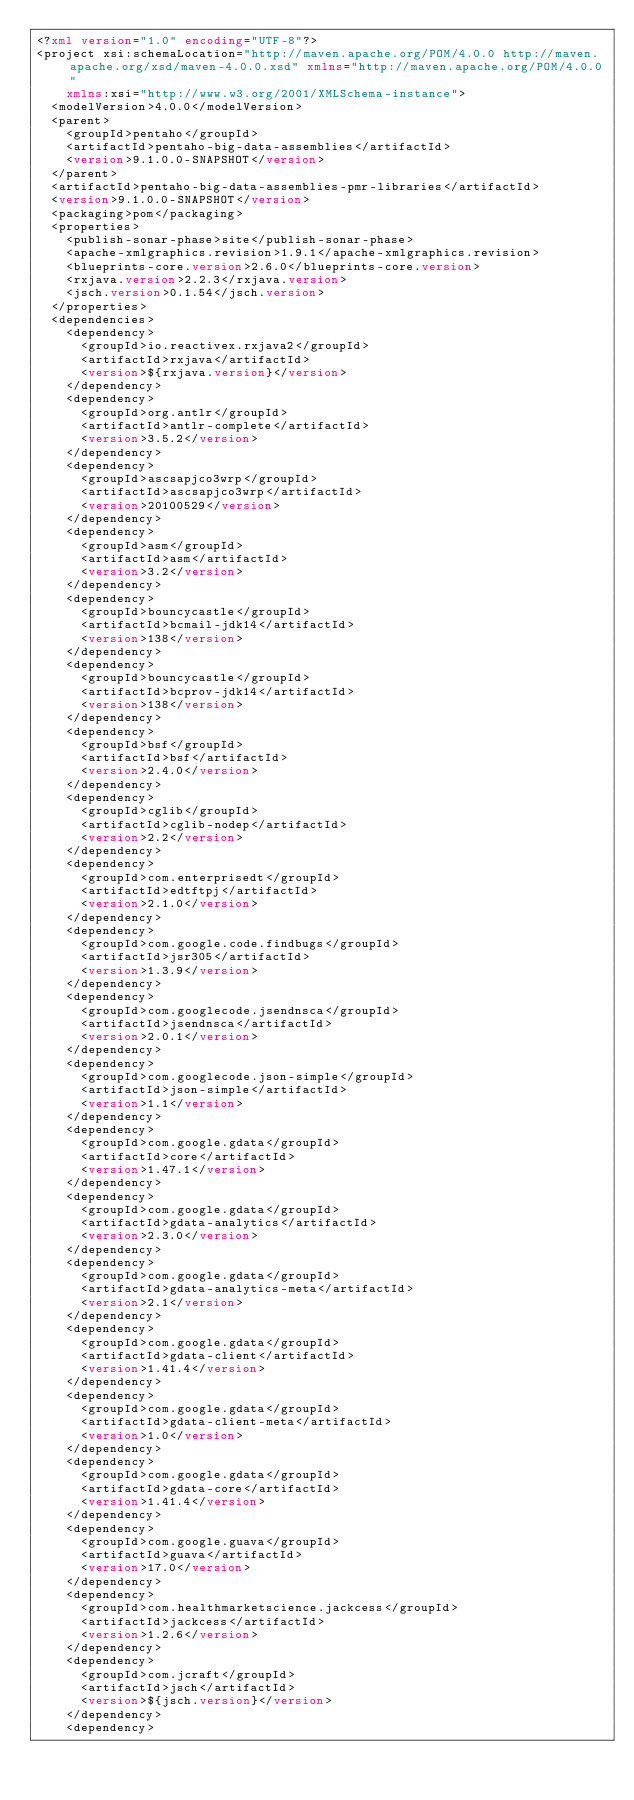<code> <loc_0><loc_0><loc_500><loc_500><_XML_><?xml version="1.0" encoding="UTF-8"?>
<project xsi:schemaLocation="http://maven.apache.org/POM/4.0.0 http://maven.apache.org/xsd/maven-4.0.0.xsd" xmlns="http://maven.apache.org/POM/4.0.0"
    xmlns:xsi="http://www.w3.org/2001/XMLSchema-instance">
  <modelVersion>4.0.0</modelVersion>
  <parent>
    <groupId>pentaho</groupId>
    <artifactId>pentaho-big-data-assemblies</artifactId>
    <version>9.1.0.0-SNAPSHOT</version>
  </parent>
  <artifactId>pentaho-big-data-assemblies-pmr-libraries</artifactId>
  <version>9.1.0.0-SNAPSHOT</version>
  <packaging>pom</packaging>
  <properties>
    <publish-sonar-phase>site</publish-sonar-phase>
    <apache-xmlgraphics.revision>1.9.1</apache-xmlgraphics.revision>
    <blueprints-core.version>2.6.0</blueprints-core.version>
    <rxjava.version>2.2.3</rxjava.version>
    <jsch.version>0.1.54</jsch.version>
  </properties>
  <dependencies>
    <dependency>
      <groupId>io.reactivex.rxjava2</groupId>
      <artifactId>rxjava</artifactId>
      <version>${rxjava.version}</version>
    </dependency>
    <dependency>
      <groupId>org.antlr</groupId>
      <artifactId>antlr-complete</artifactId>
      <version>3.5.2</version>
    </dependency>
    <dependency>
      <groupId>ascsapjco3wrp</groupId>
      <artifactId>ascsapjco3wrp</artifactId>
      <version>20100529</version>
    </dependency>
    <dependency>
      <groupId>asm</groupId>
      <artifactId>asm</artifactId>
      <version>3.2</version>
    </dependency>
    <dependency>
      <groupId>bouncycastle</groupId>
      <artifactId>bcmail-jdk14</artifactId>
      <version>138</version>
    </dependency>
    <dependency>
      <groupId>bouncycastle</groupId>
      <artifactId>bcprov-jdk14</artifactId>
      <version>138</version>
    </dependency>
    <dependency>
      <groupId>bsf</groupId>
      <artifactId>bsf</artifactId>
      <version>2.4.0</version>
    </dependency>
    <dependency>
      <groupId>cglib</groupId>
      <artifactId>cglib-nodep</artifactId>
      <version>2.2</version>
    </dependency>
    <dependency>
      <groupId>com.enterprisedt</groupId>
      <artifactId>edtftpj</artifactId>
      <version>2.1.0</version>
    </dependency>
    <dependency>
      <groupId>com.google.code.findbugs</groupId>
      <artifactId>jsr305</artifactId>
      <version>1.3.9</version>
    </dependency>
    <dependency>
      <groupId>com.googlecode.jsendnsca</groupId>
      <artifactId>jsendnsca</artifactId>
      <version>2.0.1</version>
    </dependency>
    <dependency>
      <groupId>com.googlecode.json-simple</groupId>
      <artifactId>json-simple</artifactId>
      <version>1.1</version>
    </dependency>
    <dependency>
      <groupId>com.google.gdata</groupId>
      <artifactId>core</artifactId>
      <version>1.47.1</version>
    </dependency>
    <dependency>
      <groupId>com.google.gdata</groupId>
      <artifactId>gdata-analytics</artifactId>
      <version>2.3.0</version>
    </dependency>
    <dependency>
      <groupId>com.google.gdata</groupId>
      <artifactId>gdata-analytics-meta</artifactId>
      <version>2.1</version>
    </dependency>
    <dependency>
      <groupId>com.google.gdata</groupId>
      <artifactId>gdata-client</artifactId>
      <version>1.41.4</version>
    </dependency>
    <dependency>
      <groupId>com.google.gdata</groupId>
      <artifactId>gdata-client-meta</artifactId>
      <version>1.0</version>
    </dependency>
    <dependency>
      <groupId>com.google.gdata</groupId>
      <artifactId>gdata-core</artifactId>
      <version>1.41.4</version>
    </dependency>
    <dependency>
      <groupId>com.google.guava</groupId>
      <artifactId>guava</artifactId>
      <version>17.0</version>
    </dependency>
    <dependency>
      <groupId>com.healthmarketscience.jackcess</groupId>
      <artifactId>jackcess</artifactId>
      <version>1.2.6</version>
    </dependency>
    <dependency>
      <groupId>com.jcraft</groupId>
      <artifactId>jsch</artifactId>
      <version>${jsch.version}</version>
    </dependency>
    <dependency></code> 